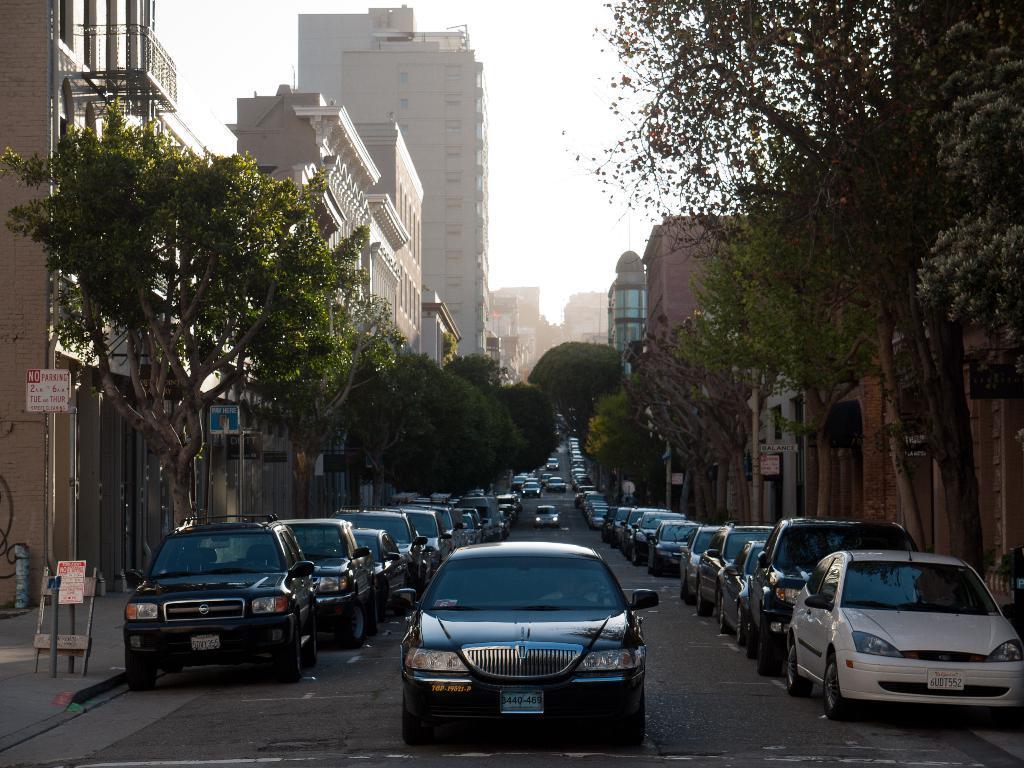How would you summarize this image in a sentence or two? In this image there are buildings and trees. At the bottom there are cars on the road. On the left there are sign boards. In the background there is sky. 